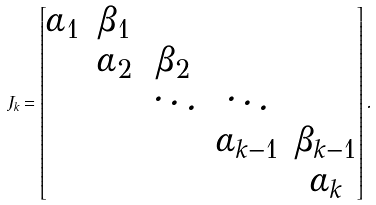Convert formula to latex. <formula><loc_0><loc_0><loc_500><loc_500>J _ { k } = \begin{bmatrix} \alpha _ { 1 } & \beta _ { 1 } \\ & \alpha _ { 2 } & \beta _ { 2 } \\ & & \ddots & \ddots \\ & & & \alpha _ { k - 1 } & \beta _ { k - 1 } \\ & & & & \alpha _ { k } \\ \end{bmatrix} .</formula> 